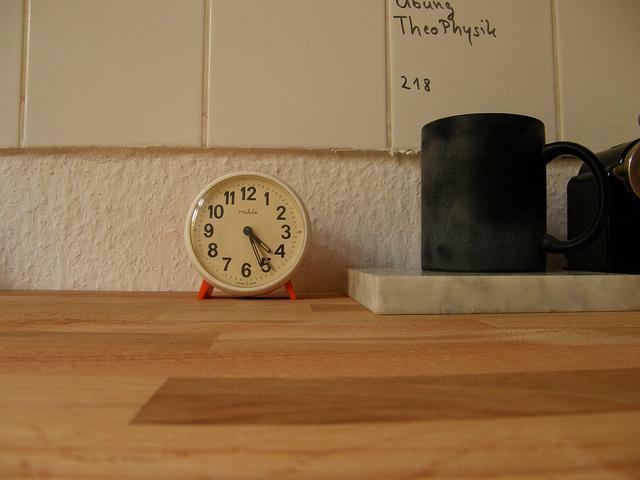How many teapots are in the photo?
Give a very brief answer. 0. How many cups can you see?
Give a very brief answer. 1. 